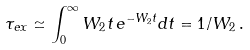Convert formula to latex. <formula><loc_0><loc_0><loc_500><loc_500>\tau _ { e x } \simeq \int _ { 0 } ^ { \infty } W _ { 2 } t \, e ^ { - W _ { 2 } t } d t = 1 / W _ { 2 } \, .</formula> 